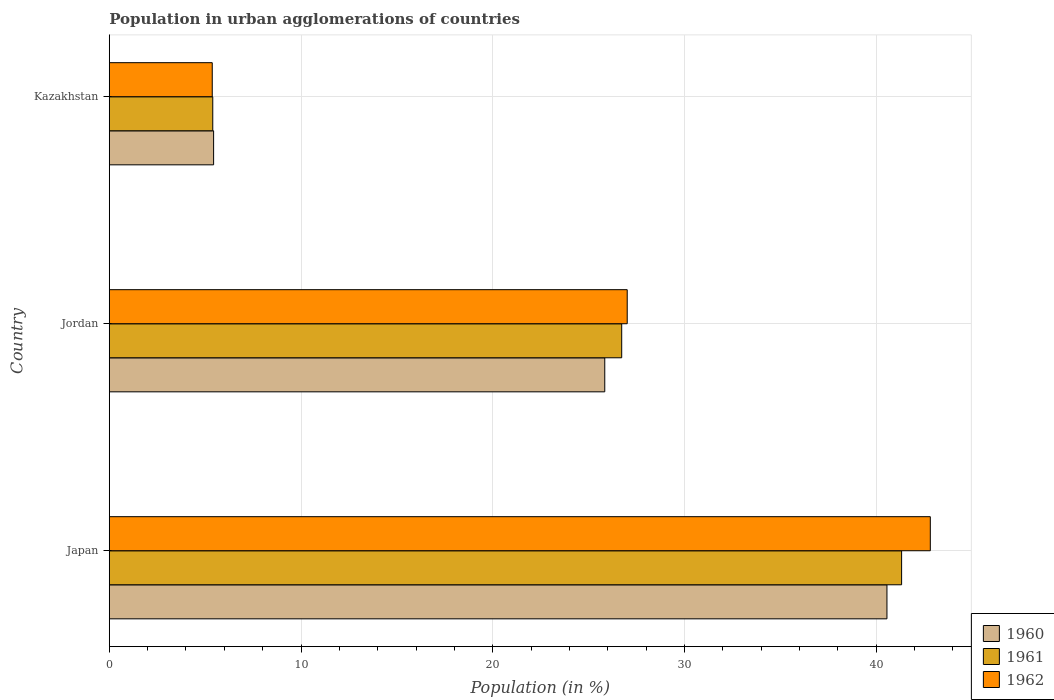How many groups of bars are there?
Your answer should be compact. 3. Are the number of bars on each tick of the Y-axis equal?
Your answer should be very brief. Yes. How many bars are there on the 3rd tick from the top?
Keep it short and to the point. 3. What is the label of the 1st group of bars from the top?
Ensure brevity in your answer.  Kazakhstan. In how many cases, is the number of bars for a given country not equal to the number of legend labels?
Give a very brief answer. 0. What is the percentage of population in urban agglomerations in 1960 in Japan?
Ensure brevity in your answer.  40.56. Across all countries, what is the maximum percentage of population in urban agglomerations in 1960?
Give a very brief answer. 40.56. Across all countries, what is the minimum percentage of population in urban agglomerations in 1961?
Your answer should be very brief. 5.4. In which country was the percentage of population in urban agglomerations in 1960 minimum?
Provide a succinct answer. Kazakhstan. What is the total percentage of population in urban agglomerations in 1962 in the graph?
Your answer should be very brief. 75.21. What is the difference between the percentage of population in urban agglomerations in 1960 in Japan and that in Jordan?
Keep it short and to the point. 14.72. What is the difference between the percentage of population in urban agglomerations in 1960 in Japan and the percentage of population in urban agglomerations in 1962 in Kazakhstan?
Give a very brief answer. 35.19. What is the average percentage of population in urban agglomerations in 1962 per country?
Offer a very short reply. 25.07. What is the difference between the percentage of population in urban agglomerations in 1961 and percentage of population in urban agglomerations in 1960 in Japan?
Your answer should be compact. 0.76. What is the ratio of the percentage of population in urban agglomerations in 1961 in Japan to that in Jordan?
Provide a short and direct response. 1.55. What is the difference between the highest and the second highest percentage of population in urban agglomerations in 1960?
Ensure brevity in your answer.  14.72. What is the difference between the highest and the lowest percentage of population in urban agglomerations in 1962?
Provide a succinct answer. 37.45. In how many countries, is the percentage of population in urban agglomerations in 1962 greater than the average percentage of population in urban agglomerations in 1962 taken over all countries?
Your response must be concise. 2. Is the sum of the percentage of population in urban agglomerations in 1961 in Japan and Jordan greater than the maximum percentage of population in urban agglomerations in 1962 across all countries?
Make the answer very short. Yes. How many bars are there?
Give a very brief answer. 9. Are all the bars in the graph horizontal?
Your answer should be compact. Yes. How many countries are there in the graph?
Offer a very short reply. 3. What is the difference between two consecutive major ticks on the X-axis?
Your answer should be compact. 10. Are the values on the major ticks of X-axis written in scientific E-notation?
Ensure brevity in your answer.  No. Does the graph contain any zero values?
Give a very brief answer. No. Does the graph contain grids?
Provide a succinct answer. Yes. Where does the legend appear in the graph?
Your response must be concise. Bottom right. How many legend labels are there?
Your response must be concise. 3. How are the legend labels stacked?
Provide a succinct answer. Vertical. What is the title of the graph?
Offer a terse response. Population in urban agglomerations of countries. What is the label or title of the X-axis?
Offer a terse response. Population (in %). What is the Population (in %) in 1960 in Japan?
Your answer should be compact. 40.56. What is the Population (in %) in 1961 in Japan?
Make the answer very short. 41.33. What is the Population (in %) of 1962 in Japan?
Offer a terse response. 42.82. What is the Population (in %) of 1960 in Jordan?
Provide a short and direct response. 25.84. What is the Population (in %) of 1961 in Jordan?
Your response must be concise. 26.73. What is the Population (in %) in 1962 in Jordan?
Ensure brevity in your answer.  27.01. What is the Population (in %) of 1960 in Kazakhstan?
Ensure brevity in your answer.  5.44. What is the Population (in %) in 1961 in Kazakhstan?
Provide a short and direct response. 5.4. What is the Population (in %) in 1962 in Kazakhstan?
Provide a succinct answer. 5.37. Across all countries, what is the maximum Population (in %) in 1960?
Ensure brevity in your answer.  40.56. Across all countries, what is the maximum Population (in %) of 1961?
Your answer should be very brief. 41.33. Across all countries, what is the maximum Population (in %) of 1962?
Make the answer very short. 42.82. Across all countries, what is the minimum Population (in %) of 1960?
Offer a very short reply. 5.44. Across all countries, what is the minimum Population (in %) of 1961?
Provide a succinct answer. 5.4. Across all countries, what is the minimum Population (in %) in 1962?
Your response must be concise. 5.37. What is the total Population (in %) in 1960 in the graph?
Ensure brevity in your answer.  71.85. What is the total Population (in %) of 1961 in the graph?
Provide a succinct answer. 73.45. What is the total Population (in %) of 1962 in the graph?
Offer a terse response. 75.21. What is the difference between the Population (in %) of 1960 in Japan and that in Jordan?
Give a very brief answer. 14.72. What is the difference between the Population (in %) in 1961 in Japan and that in Jordan?
Offer a terse response. 14.6. What is the difference between the Population (in %) of 1962 in Japan and that in Jordan?
Provide a succinct answer. 15.81. What is the difference between the Population (in %) in 1960 in Japan and that in Kazakhstan?
Your response must be concise. 35.12. What is the difference between the Population (in %) of 1961 in Japan and that in Kazakhstan?
Your response must be concise. 35.93. What is the difference between the Population (in %) of 1962 in Japan and that in Kazakhstan?
Make the answer very short. 37.45. What is the difference between the Population (in %) in 1960 in Jordan and that in Kazakhstan?
Keep it short and to the point. 20.4. What is the difference between the Population (in %) in 1961 in Jordan and that in Kazakhstan?
Provide a short and direct response. 21.33. What is the difference between the Population (in %) in 1962 in Jordan and that in Kazakhstan?
Your answer should be compact. 21.64. What is the difference between the Population (in %) in 1960 in Japan and the Population (in %) in 1961 in Jordan?
Your answer should be compact. 13.83. What is the difference between the Population (in %) in 1960 in Japan and the Population (in %) in 1962 in Jordan?
Give a very brief answer. 13.55. What is the difference between the Population (in %) of 1961 in Japan and the Population (in %) of 1962 in Jordan?
Provide a succinct answer. 14.31. What is the difference between the Population (in %) in 1960 in Japan and the Population (in %) in 1961 in Kazakhstan?
Ensure brevity in your answer.  35.16. What is the difference between the Population (in %) in 1960 in Japan and the Population (in %) in 1962 in Kazakhstan?
Your answer should be compact. 35.19. What is the difference between the Population (in %) in 1961 in Japan and the Population (in %) in 1962 in Kazakhstan?
Offer a very short reply. 35.95. What is the difference between the Population (in %) in 1960 in Jordan and the Population (in %) in 1961 in Kazakhstan?
Your response must be concise. 20.44. What is the difference between the Population (in %) of 1960 in Jordan and the Population (in %) of 1962 in Kazakhstan?
Give a very brief answer. 20.47. What is the difference between the Population (in %) in 1961 in Jordan and the Population (in %) in 1962 in Kazakhstan?
Provide a succinct answer. 21.36. What is the average Population (in %) of 1960 per country?
Keep it short and to the point. 23.95. What is the average Population (in %) in 1961 per country?
Offer a terse response. 24.48. What is the average Population (in %) of 1962 per country?
Make the answer very short. 25.07. What is the difference between the Population (in %) of 1960 and Population (in %) of 1961 in Japan?
Ensure brevity in your answer.  -0.76. What is the difference between the Population (in %) of 1960 and Population (in %) of 1962 in Japan?
Give a very brief answer. -2.26. What is the difference between the Population (in %) in 1961 and Population (in %) in 1962 in Japan?
Provide a short and direct response. -1.5. What is the difference between the Population (in %) of 1960 and Population (in %) of 1961 in Jordan?
Offer a terse response. -0.88. What is the difference between the Population (in %) of 1960 and Population (in %) of 1962 in Jordan?
Ensure brevity in your answer.  -1.17. What is the difference between the Population (in %) in 1961 and Population (in %) in 1962 in Jordan?
Give a very brief answer. -0.29. What is the difference between the Population (in %) in 1960 and Population (in %) in 1961 in Kazakhstan?
Offer a terse response. 0.04. What is the difference between the Population (in %) of 1960 and Population (in %) of 1962 in Kazakhstan?
Keep it short and to the point. 0.07. What is the difference between the Population (in %) in 1961 and Population (in %) in 1962 in Kazakhstan?
Provide a short and direct response. 0.03. What is the ratio of the Population (in %) of 1960 in Japan to that in Jordan?
Offer a very short reply. 1.57. What is the ratio of the Population (in %) of 1961 in Japan to that in Jordan?
Ensure brevity in your answer.  1.55. What is the ratio of the Population (in %) of 1962 in Japan to that in Jordan?
Offer a terse response. 1.59. What is the ratio of the Population (in %) of 1960 in Japan to that in Kazakhstan?
Offer a terse response. 7.45. What is the ratio of the Population (in %) in 1961 in Japan to that in Kazakhstan?
Your response must be concise. 7.66. What is the ratio of the Population (in %) in 1962 in Japan to that in Kazakhstan?
Your answer should be very brief. 7.97. What is the ratio of the Population (in %) in 1960 in Jordan to that in Kazakhstan?
Offer a terse response. 4.75. What is the ratio of the Population (in %) of 1961 in Jordan to that in Kazakhstan?
Your answer should be compact. 4.95. What is the ratio of the Population (in %) in 1962 in Jordan to that in Kazakhstan?
Offer a very short reply. 5.03. What is the difference between the highest and the second highest Population (in %) in 1960?
Provide a short and direct response. 14.72. What is the difference between the highest and the second highest Population (in %) in 1961?
Your answer should be very brief. 14.6. What is the difference between the highest and the second highest Population (in %) in 1962?
Give a very brief answer. 15.81. What is the difference between the highest and the lowest Population (in %) of 1960?
Your answer should be very brief. 35.12. What is the difference between the highest and the lowest Population (in %) in 1961?
Ensure brevity in your answer.  35.93. What is the difference between the highest and the lowest Population (in %) of 1962?
Provide a short and direct response. 37.45. 